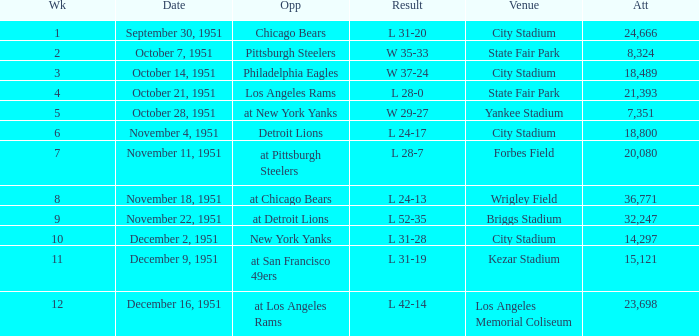Which venue hosted the Los Angeles Rams as an opponent? State Fair Park. 